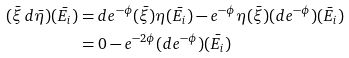<formula> <loc_0><loc_0><loc_500><loc_500>( \bar { \xi } \, d \bar { \eta } ) ( \bar { E _ { i } } ) & = d e ^ { - \phi } ( \bar { \xi } ) \eta ( \bar { E _ { i } } ) - e ^ { - \phi } \eta ( \bar { \xi } ) ( d e ^ { - \phi } ) ( \bar { E _ { i } } ) \\ & = 0 - e ^ { - 2 \phi } ( d e ^ { - \phi } ) ( \bar { E _ { i } } )</formula> 